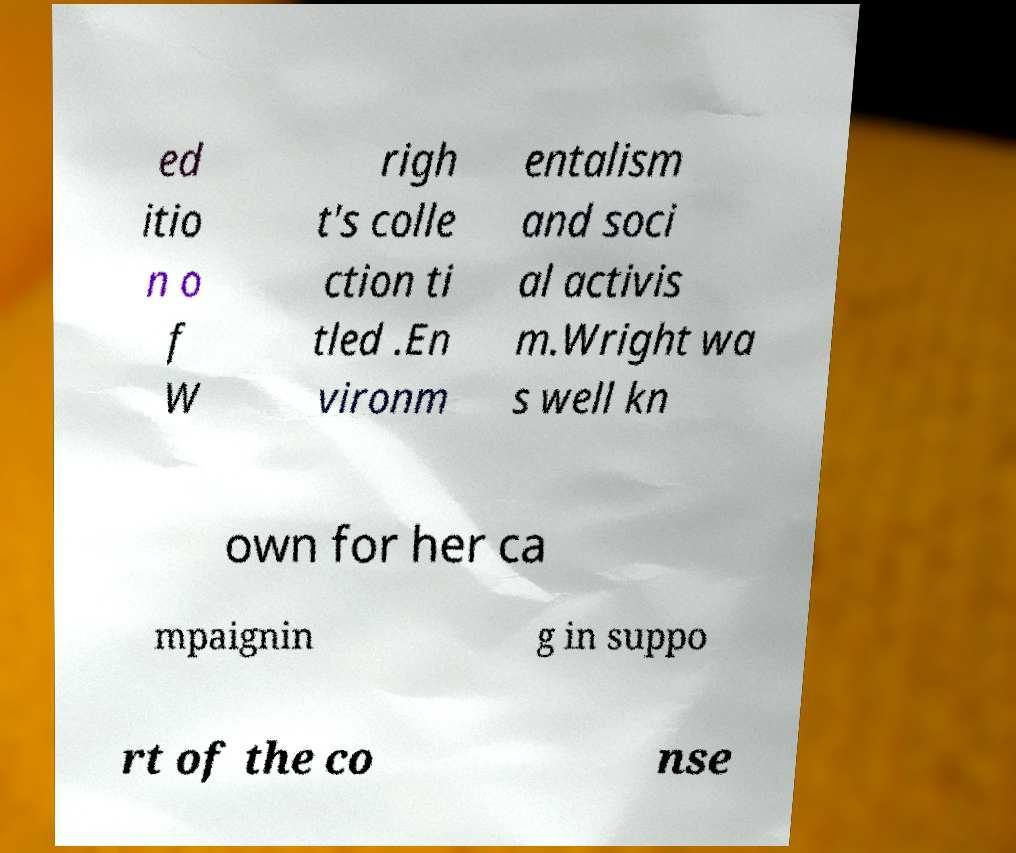Could you extract and type out the text from this image? ed itio n o f W righ t's colle ction ti tled .En vironm entalism and soci al activis m.Wright wa s well kn own for her ca mpaignin g in suppo rt of the co nse 